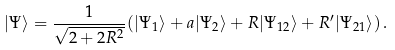<formula> <loc_0><loc_0><loc_500><loc_500>| \Psi \rangle = \frac { 1 } { \sqrt { 2 + 2 R ^ { 2 } } } ( | \Psi _ { 1 } \rangle + a | \Psi _ { 2 } \rangle + R | \Psi _ { 1 2 } \rangle + R ^ { \prime } | \Psi _ { 2 1 } \rangle ) \, .</formula> 